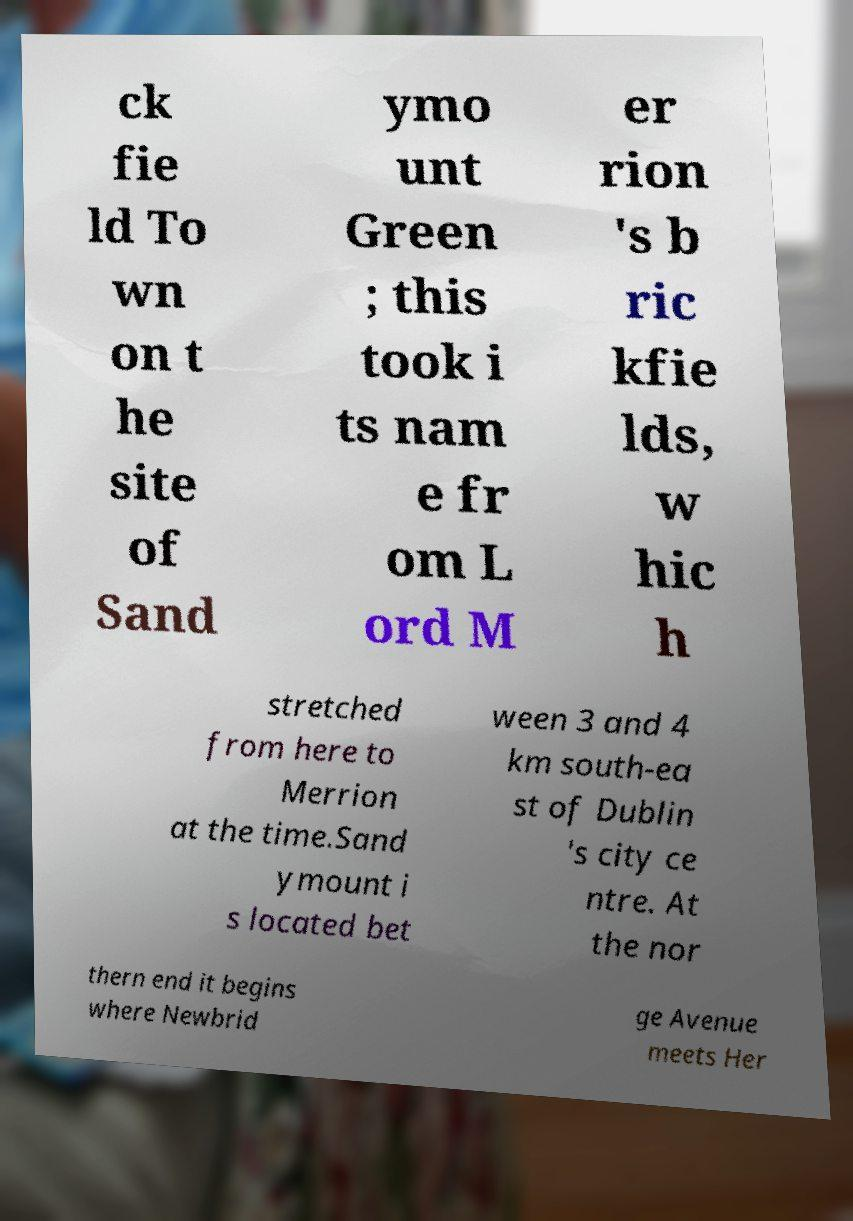There's text embedded in this image that I need extracted. Can you transcribe it verbatim? ck fie ld To wn on t he site of Sand ymo unt Green ; this took i ts nam e fr om L ord M er rion 's b ric kfie lds, w hic h stretched from here to Merrion at the time.Sand ymount i s located bet ween 3 and 4 km south-ea st of Dublin 's city ce ntre. At the nor thern end it begins where Newbrid ge Avenue meets Her 